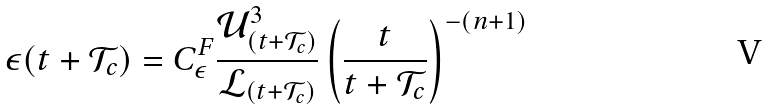Convert formula to latex. <formula><loc_0><loc_0><loc_500><loc_500>\epsilon ( t + \mathcal { T } _ { c } ) = C _ { \epsilon } ^ { F } \frac { \mathcal { U } _ { ( t + \mathcal { T } _ { c } ) } ^ { 3 } } { \mathcal { L } _ { ( t + \mathcal { T } _ { c } ) } } \left ( \frac { t } { t + \mathcal { T } _ { c } } \right ) ^ { - ( n + 1 ) }</formula> 